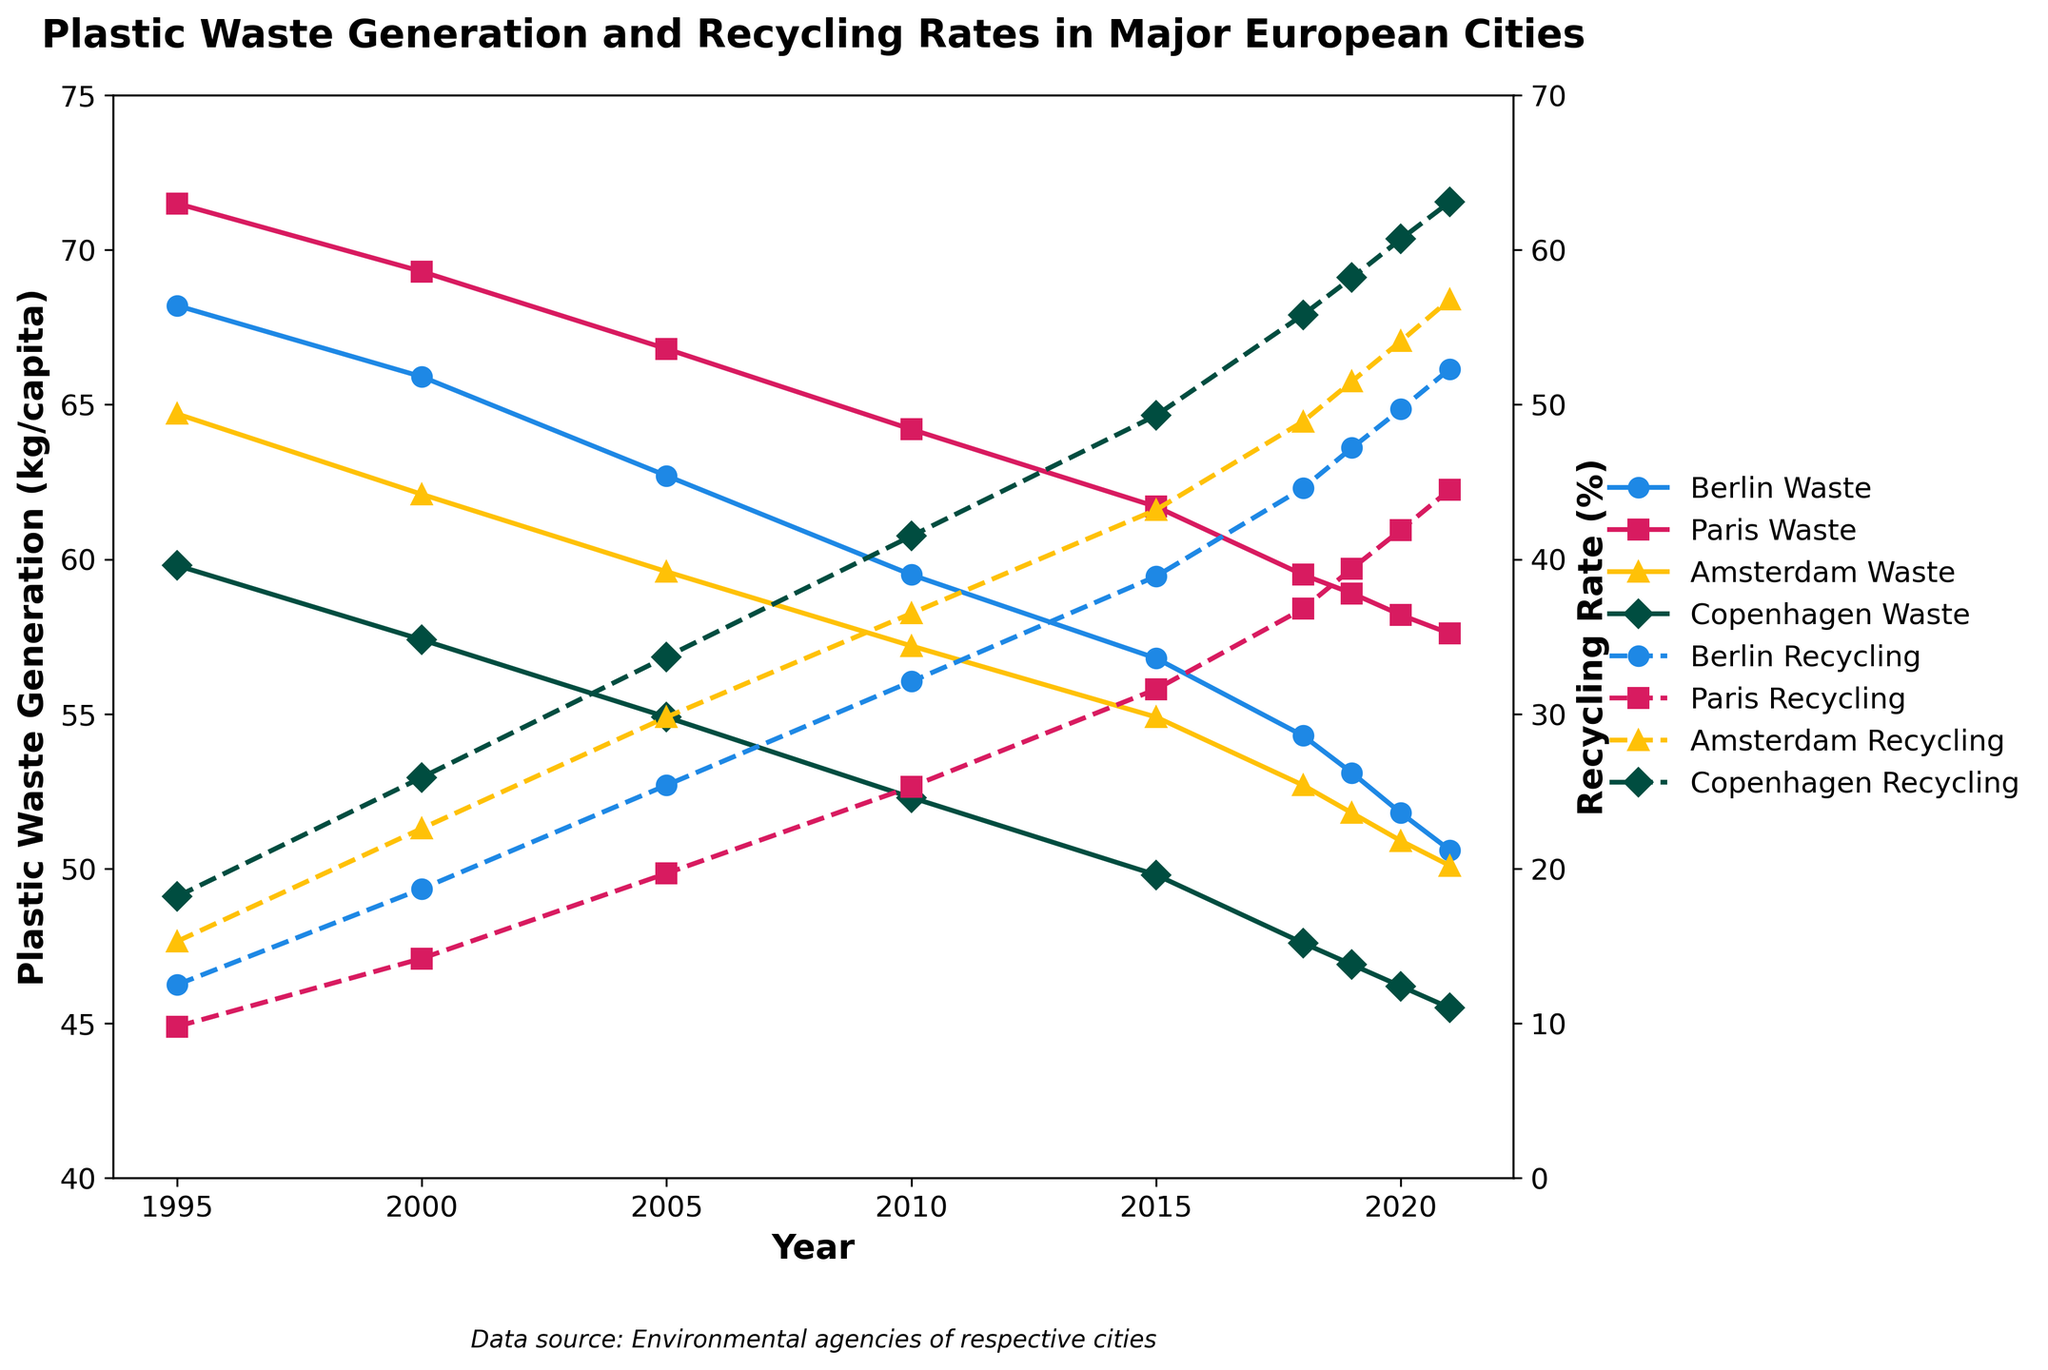Which city had the highest plastic waste generation in 1995? Look at the values for plastic waste generation in 1995. Berlin had 68.2 kg, Paris had 71.5 kg, Amsterdam had 64.7 kg, and Copenhagen had 59.8 kg. Paris has the highest value.
Answer: Paris How did the plastic waste generation in Amsterdam change from 1995 to 2021? In 1995, Amsterdam's plastic waste generation was 64.7 kg per capita. By 2021, it decreased to 50.1 kg per capita. The change is 64.7 - 50.1 = 14.6 kg decrease.
Answer: Decreased by 14.6 kg Which city shows the highest increase in recycling rate from 1995 to 2021? Look at the recycling rates for all cities in 1995 and 2021. Calculate the increase for each city: Berlin (52.3 - 12.5 = 39.8%), Paris (44.5 - 9.8 = 34.7%), Amsterdam (56.8 - 15.3 = 41.5%), Copenhagen (63.1 - 18.2 = 44.9%). Copenhagen has the highest increase.
Answer: Copenhagen What was the average recycling rate in Berlin from 1995 to 2021? Sum the recycling rates of Berlin for each year and divide by the number of years. (12.5 + 18.7 + 25.4 + 32.1 + 38.9 + 44.6 + 47.2 + 49.7 + 52.3)/9 = 35.7%
Answer: 35.7% In which year did Copenhagen have a plastic waste generation lower than 50 kg per capita for the first time? Look at Copenhagen's plastic waste generation over the years. In 2015, it was 49.8 kg, marking the first time below 50 kg per capita.
Answer: 2015 Compare the recycling rates of Berlin and Paris in 2021. Which city had a higher rate? Berlin had a recycling rate of 52.3%, and Paris had 44.5% in 2021. Berlin had a higher rate.
Answer: Berlin Which year saw the smallest gap between plastic waste generation and recycling rates in Amsterdam? Look for the year where the difference between waste generation and recycling rates in Amsterdam is the smallest: 2019 (51.8 - 51.5 = 0.3 kg) has the smallest gap.
Answer: 2019 What is the trend of plastic waste generation in Paris from 1995 to 2021? Observe the trend line for Paris from 1995 to 2021. The plastic waste generation decreases from 71.5 kg in 1995 to 57.6 kg in 2021.
Answer: Decreasing By how much did Copenhagen's recycling rate change between 2018 and 2021? The recycling rate for Copenhagen in 2018 was 55.8%, and it increased to 63.1% in 2021. The change is 63.1 - 55.8 = 7.3%.
Answer: Increased by 7.3% How does the recycling rate in Amsterdam in 2021 compare to the recycling rate in Berlin in the same year? Amsterdam had a recycling rate of 56.8% in 2021, while Berlin had 52.3%. Amsterdam's rate is higher.
Answer: Amsterdam 